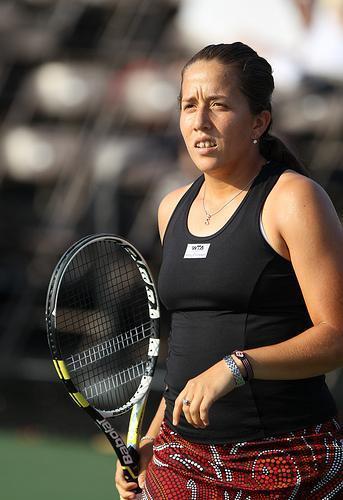How many people are there?
Give a very brief answer. 1. 